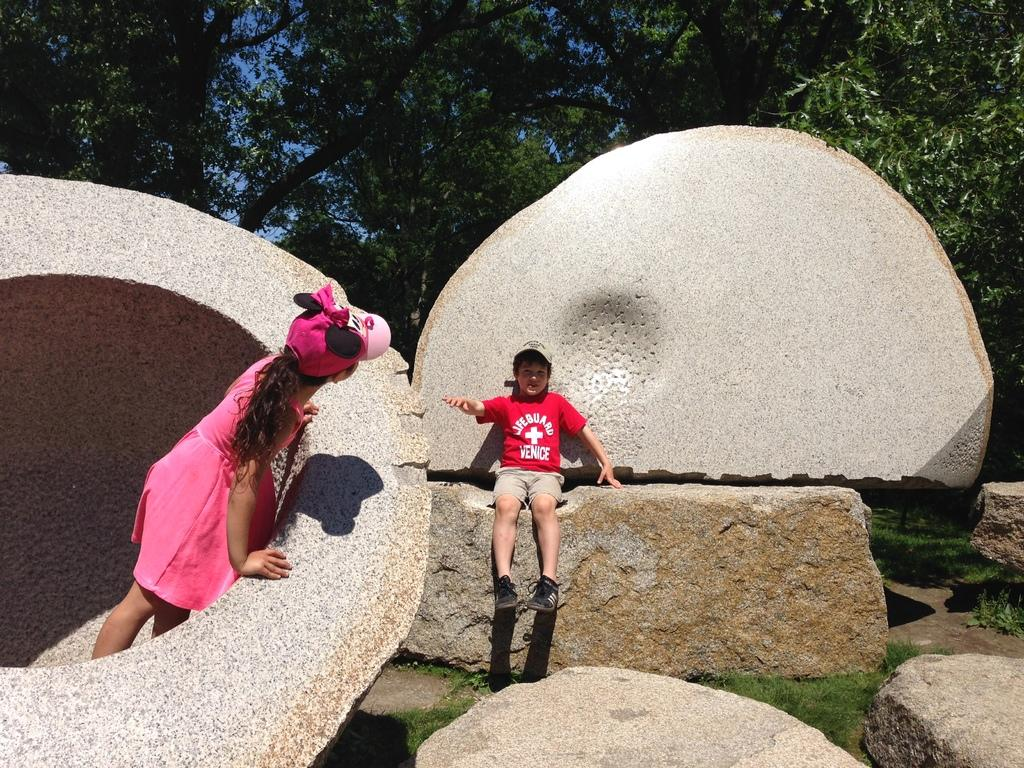How many kids are present in the image? There are two kids in the image. What are the kids doing in the image? The kids are playing on rocks. What can be seen in the background of the image? There are trees in the background of the image. Where is the mom of the kids in the image? There is no mom present in the image. What type of stone is being used by the kids to play in the image? The provided facts do not specify the type of stone being used by the kids to play. 